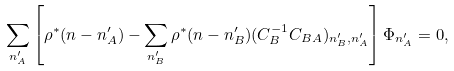Convert formula to latex. <formula><loc_0><loc_0><loc_500><loc_500>\sum _ { n ^ { \prime } _ { A } } \left [ \rho ^ { * } ( n - n ^ { \prime } _ { A } ) - \sum _ { n ^ { \prime } _ { B } } \rho ^ { * } ( n - n ^ { \prime } _ { B } ) ( C _ { B } ^ { - 1 } C _ { B A } ) _ { n ^ { \prime } _ { B } , n ^ { \prime } _ { A } } \right ] \Phi _ { n ^ { \prime } _ { A } } = 0 ,</formula> 